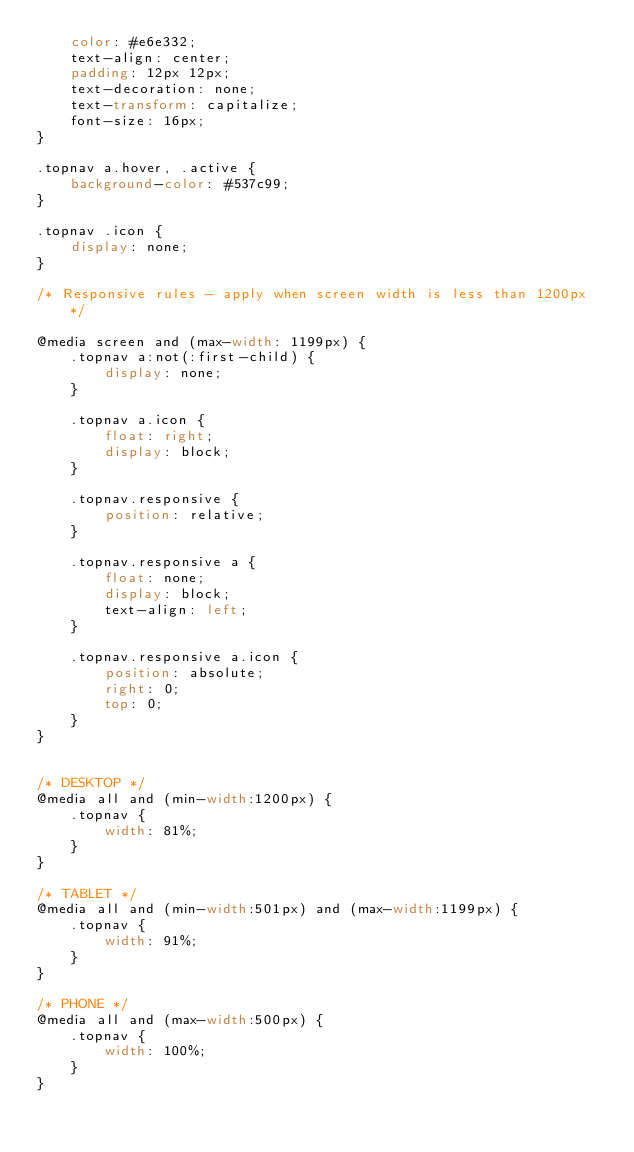Convert code to text. <code><loc_0><loc_0><loc_500><loc_500><_CSS_>    color: #e6e332;
    text-align: center;
    padding: 12px 12px;
    text-decoration: none;
    text-transform: capitalize;
    font-size: 16px;
}

.topnav a.hover, .active {
    background-color: #537c99;
}

.topnav .icon {
    display: none;
}

/* Responsive rules - apply when screen width is less than 1200px */

@media screen and (max-width: 1199px) {
    .topnav a:not(:first-child) {
        display: none;
    }
    
    .topnav a.icon {
        float: right;
        display: block;
    }
    
    .topnav.responsive {
        position: relative;
    }
    
    .topnav.responsive a {
        float: none;
        display: block;
        text-align: left;
    }
    
    .topnav.responsive a.icon {
        position: absolute;
        right: 0;
        top: 0;
    }
}


/* DESKTOP */
@media all and (min-width:1200px) {
    .topnav {
        width: 81%;
    }
}

/* TABLET */
@media all and (min-width:501px) and (max-width:1199px) {
    .topnav {
        width: 91%;
    }
}

/* PHONE */
@media all and (max-width:500px) {
    .topnav {
        width: 100%;
    }
}</code> 